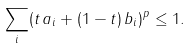Convert formula to latex. <formula><loc_0><loc_0><loc_500><loc_500>\sum _ { i } ( t \, a _ { i } + ( 1 - t ) \, b _ { i } ) ^ { p } \leq 1 .</formula> 